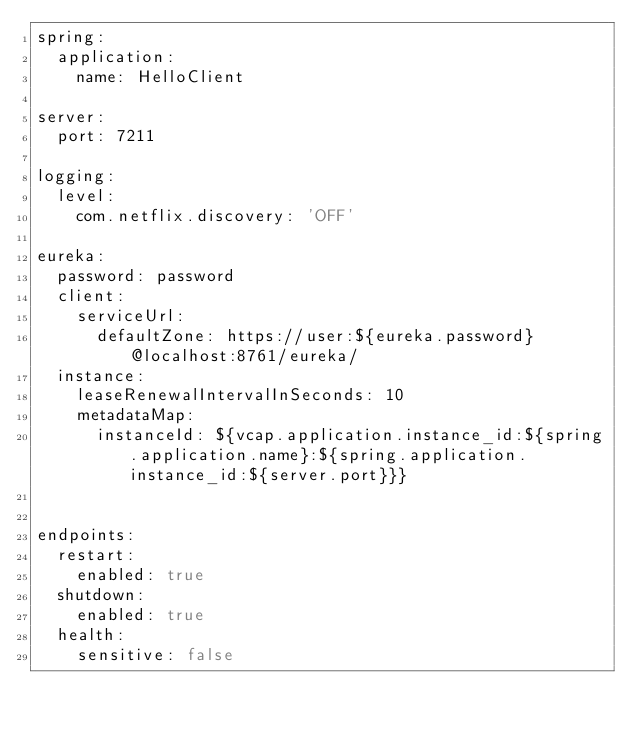Convert code to text. <code><loc_0><loc_0><loc_500><loc_500><_YAML_>spring:
  application:
    name: HelloClient

server:
  port: 7211

logging:
  level:
    com.netflix.discovery: 'OFF'

eureka:
  password: password
  client:
    serviceUrl:
      defaultZone: https://user:${eureka.password}@localhost:8761/eureka/
  instance:
    leaseRenewalIntervalInSeconds: 10
    metadataMap:
      instanceId: ${vcap.application.instance_id:${spring.application.name}:${spring.application.instance_id:${server.port}}}


endpoints:
  restart:
    enabled: true
  shutdown:
    enabled: true
  health:
    sensitive: false</code> 